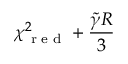Convert formula to latex. <formula><loc_0><loc_0><loc_500><loc_500>\chi _ { r e d } ^ { 2 } + \frac { \tilde { \gamma } R } { 3 }</formula> 